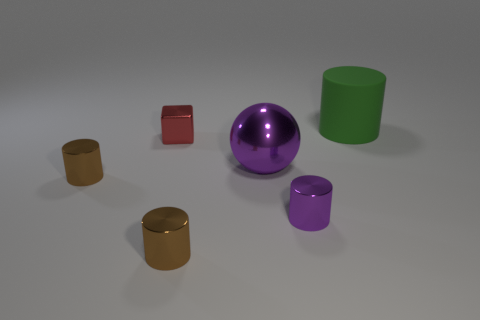Subtract 1 cylinders. How many cylinders are left? 3 Subtract all green cylinders. How many cylinders are left? 3 Subtract all matte cylinders. How many cylinders are left? 3 Add 2 brown cylinders. How many objects exist? 8 Subtract all cyan cylinders. Subtract all cyan balls. How many cylinders are left? 4 Subtract all balls. How many objects are left? 5 Add 1 tiny red things. How many tiny red things exist? 2 Subtract 0 gray cubes. How many objects are left? 6 Subtract all green cylinders. Subtract all tiny brown cylinders. How many objects are left? 3 Add 1 tiny brown shiny cylinders. How many tiny brown shiny cylinders are left? 3 